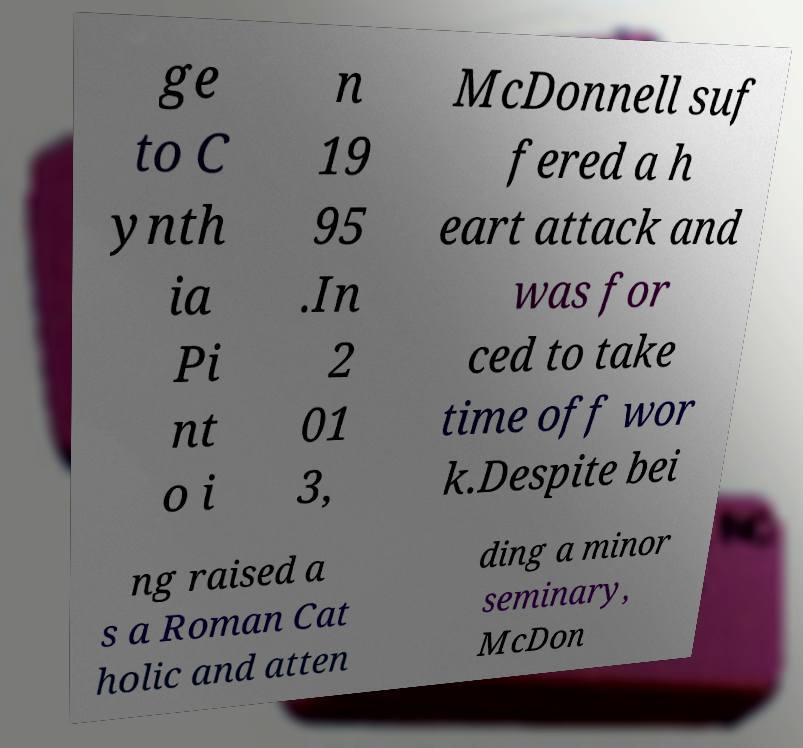Please read and relay the text visible in this image. What does it say? ge to C ynth ia Pi nt o i n 19 95 .In 2 01 3, McDonnell suf fered a h eart attack and was for ced to take time off wor k.Despite bei ng raised a s a Roman Cat holic and atten ding a minor seminary, McDon 